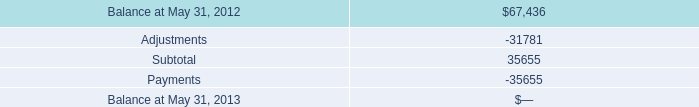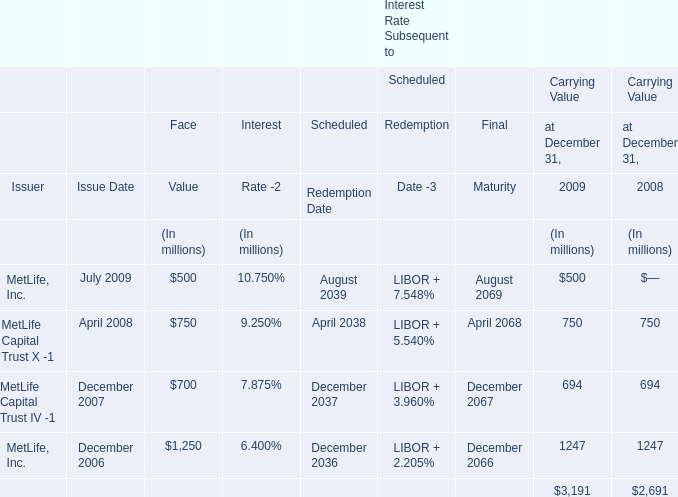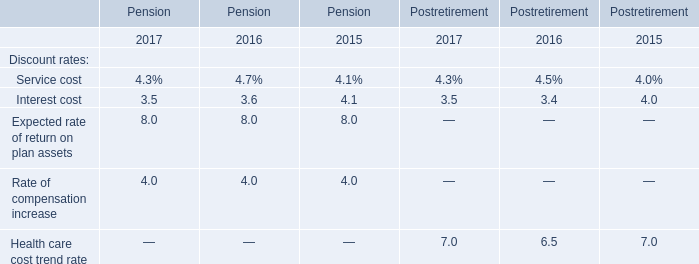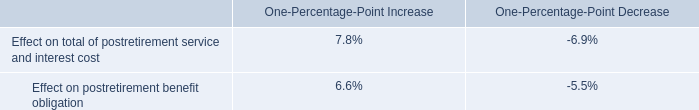What is the sum of Balance at May 31, 2012, MetLife, Inc. of Interest Rate Subsequent to Final Maturity is, and MetLife, Inc. of Interest Rate Subsequent to Final Maturity is ? 
Computations: ((67436.0 + 2066.0) + 2069.0)
Answer: 71571.0. 